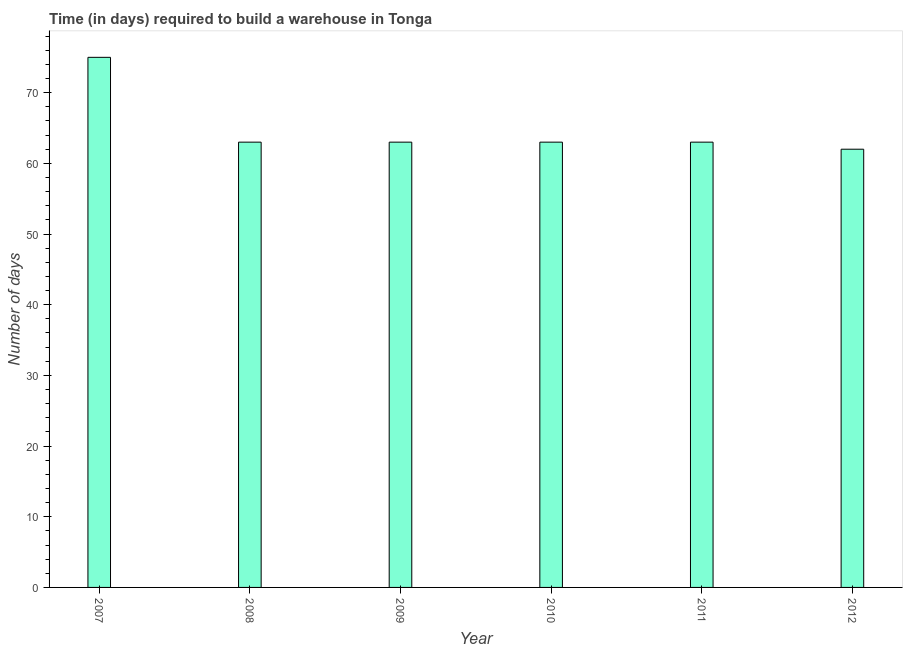Does the graph contain any zero values?
Give a very brief answer. No. Does the graph contain grids?
Make the answer very short. No. What is the title of the graph?
Offer a terse response. Time (in days) required to build a warehouse in Tonga. What is the label or title of the X-axis?
Your answer should be very brief. Year. What is the label or title of the Y-axis?
Offer a terse response. Number of days. What is the time required to build a warehouse in 2011?
Provide a succinct answer. 63. Across all years, what is the maximum time required to build a warehouse?
Keep it short and to the point. 75. In which year was the time required to build a warehouse minimum?
Your answer should be very brief. 2012. What is the sum of the time required to build a warehouse?
Make the answer very short. 389. What is the difference between the time required to build a warehouse in 2008 and 2011?
Offer a very short reply. 0. What is the average time required to build a warehouse per year?
Provide a succinct answer. 64. What is the median time required to build a warehouse?
Your response must be concise. 63. In how many years, is the time required to build a warehouse greater than 42 days?
Provide a succinct answer. 6. Is the time required to build a warehouse in 2007 less than that in 2008?
Your response must be concise. No. What is the difference between the highest and the second highest time required to build a warehouse?
Your answer should be compact. 12. What is the difference between the highest and the lowest time required to build a warehouse?
Provide a short and direct response. 13. In how many years, is the time required to build a warehouse greater than the average time required to build a warehouse taken over all years?
Make the answer very short. 1. Are all the bars in the graph horizontal?
Keep it short and to the point. No. How many years are there in the graph?
Your response must be concise. 6. What is the difference between two consecutive major ticks on the Y-axis?
Make the answer very short. 10. What is the Number of days of 2007?
Offer a terse response. 75. What is the Number of days of 2008?
Your response must be concise. 63. What is the Number of days of 2011?
Your response must be concise. 63. What is the Number of days of 2012?
Keep it short and to the point. 62. What is the difference between the Number of days in 2007 and 2009?
Give a very brief answer. 12. What is the difference between the Number of days in 2007 and 2011?
Your answer should be very brief. 12. What is the difference between the Number of days in 2007 and 2012?
Give a very brief answer. 13. What is the difference between the Number of days in 2008 and 2009?
Your answer should be compact. 0. What is the difference between the Number of days in 2009 and 2012?
Make the answer very short. 1. What is the difference between the Number of days in 2010 and 2011?
Keep it short and to the point. 0. What is the difference between the Number of days in 2011 and 2012?
Give a very brief answer. 1. What is the ratio of the Number of days in 2007 to that in 2008?
Offer a very short reply. 1.19. What is the ratio of the Number of days in 2007 to that in 2009?
Give a very brief answer. 1.19. What is the ratio of the Number of days in 2007 to that in 2010?
Give a very brief answer. 1.19. What is the ratio of the Number of days in 2007 to that in 2011?
Provide a succinct answer. 1.19. What is the ratio of the Number of days in 2007 to that in 2012?
Your answer should be very brief. 1.21. What is the ratio of the Number of days in 2008 to that in 2009?
Give a very brief answer. 1. What is the ratio of the Number of days in 2009 to that in 2012?
Provide a succinct answer. 1.02. What is the ratio of the Number of days in 2010 to that in 2011?
Ensure brevity in your answer.  1. What is the ratio of the Number of days in 2010 to that in 2012?
Keep it short and to the point. 1.02. 